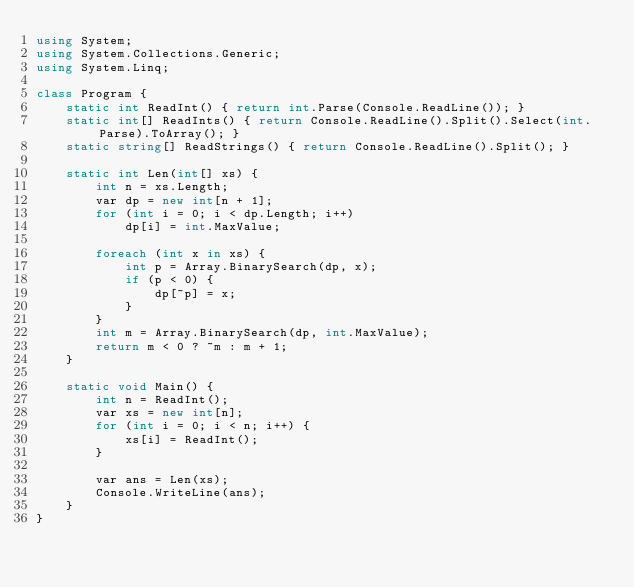Convert code to text. <code><loc_0><loc_0><loc_500><loc_500><_C#_>using System;
using System.Collections.Generic;
using System.Linq;

class Program {
    static int ReadInt() { return int.Parse(Console.ReadLine()); }
    static int[] ReadInts() { return Console.ReadLine().Split().Select(int.Parse).ToArray(); }
    static string[] ReadStrings() { return Console.ReadLine().Split(); }

    static int Len(int[] xs) {
        int n = xs.Length;
        var dp = new int[n + 1];
        for (int i = 0; i < dp.Length; i++)
            dp[i] = int.MaxValue;

        foreach (int x in xs) {
            int p = Array.BinarySearch(dp, x);
            if (p < 0) {
                dp[~p] = x;
            }
        }
        int m = Array.BinarySearch(dp, int.MaxValue);
        return m < 0 ? ~m : m + 1;
    }

    static void Main() {
        int n = ReadInt();
        var xs = new int[n];
        for (int i = 0; i < n; i++) {
            xs[i] = ReadInt();
        }

        var ans = Len(xs);
        Console.WriteLine(ans);
    }
}</code> 